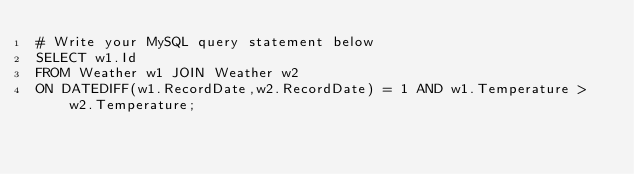Convert code to text. <code><loc_0><loc_0><loc_500><loc_500><_SQL_># Write your MySQL query statement below
SELECT w1.Id 
FROM Weather w1 JOIN Weather w2
ON DATEDIFF(w1.RecordDate,w2.RecordDate) = 1 AND w1.Temperature > w2.Temperature;
</code> 